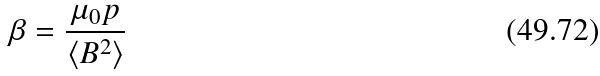Convert formula to latex. <formula><loc_0><loc_0><loc_500><loc_500>\beta = \frac { \mu _ { 0 } p } { \langle B ^ { 2 } \rangle }</formula> 